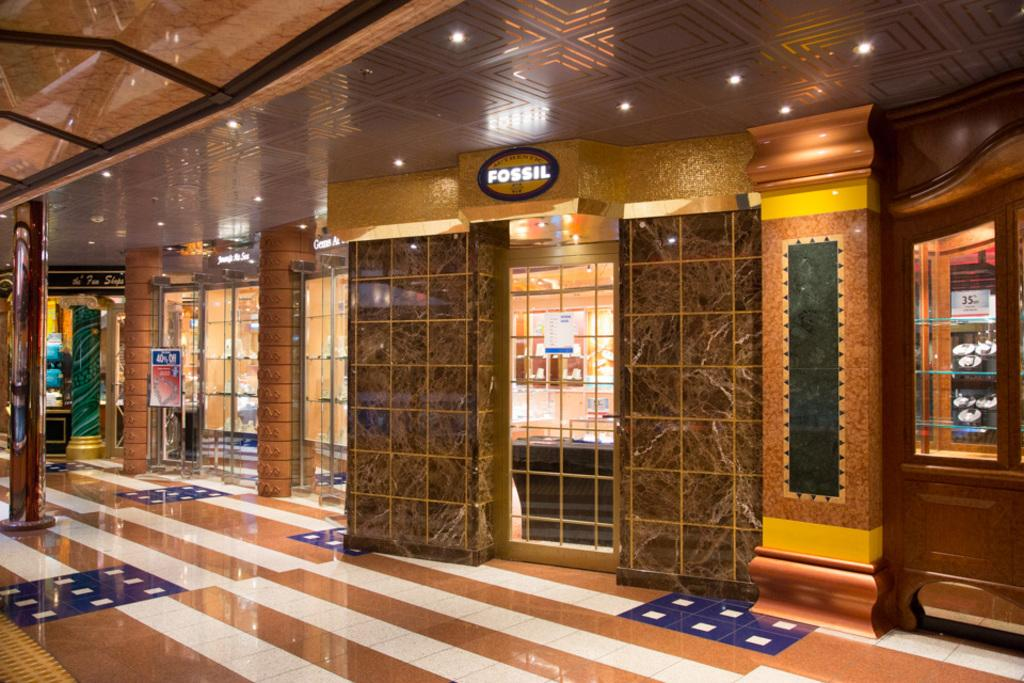Where was the image taken? The image was taken inside a building. What architectural features can be seen in the image? There are pillars in the image. What decorative elements are present in the image? There are posters in the image. What functional elements can be seen in the image? There are doors, grills, and shelves in the image. What type of text is visible in the image? There is text in the image. What type of lighting is present in the image? There are lighting's in the image. What is the surface that the other elements are placed on or attached to? There is a floor in the image. How many stars can be seen on the hill in the image? There is no hill or stars present in the image. What type of order is being followed by the elements in the image? There is no specific order being followed by the elements in the image; they are arranged in a way that is functional and visually appealing. 